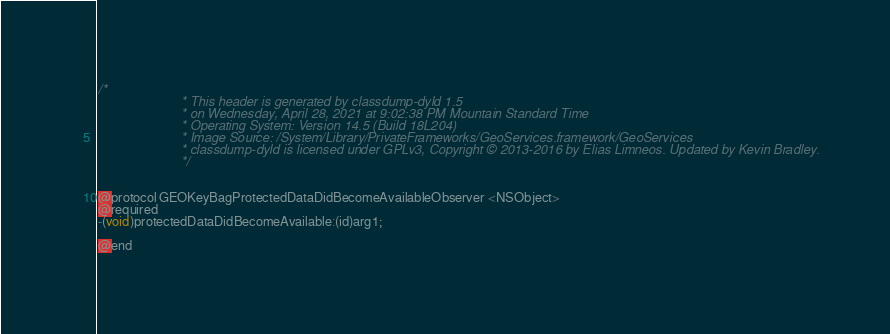Convert code to text. <code><loc_0><loc_0><loc_500><loc_500><_C_>/*
                       * This header is generated by classdump-dyld 1.5
                       * on Wednesday, April 28, 2021 at 9:02:38 PM Mountain Standard Time
                       * Operating System: Version 14.5 (Build 18L204)
                       * Image Source: /System/Library/PrivateFrameworks/GeoServices.framework/GeoServices
                       * classdump-dyld is licensed under GPLv3, Copyright © 2013-2016 by Elias Limneos. Updated by Kevin Bradley.
                       */


@protocol GEOKeyBagProtectedDataDidBecomeAvailableObserver <NSObject>
@required
-(void)protectedDataDidBecomeAvailable:(id)arg1;

@end

</code> 